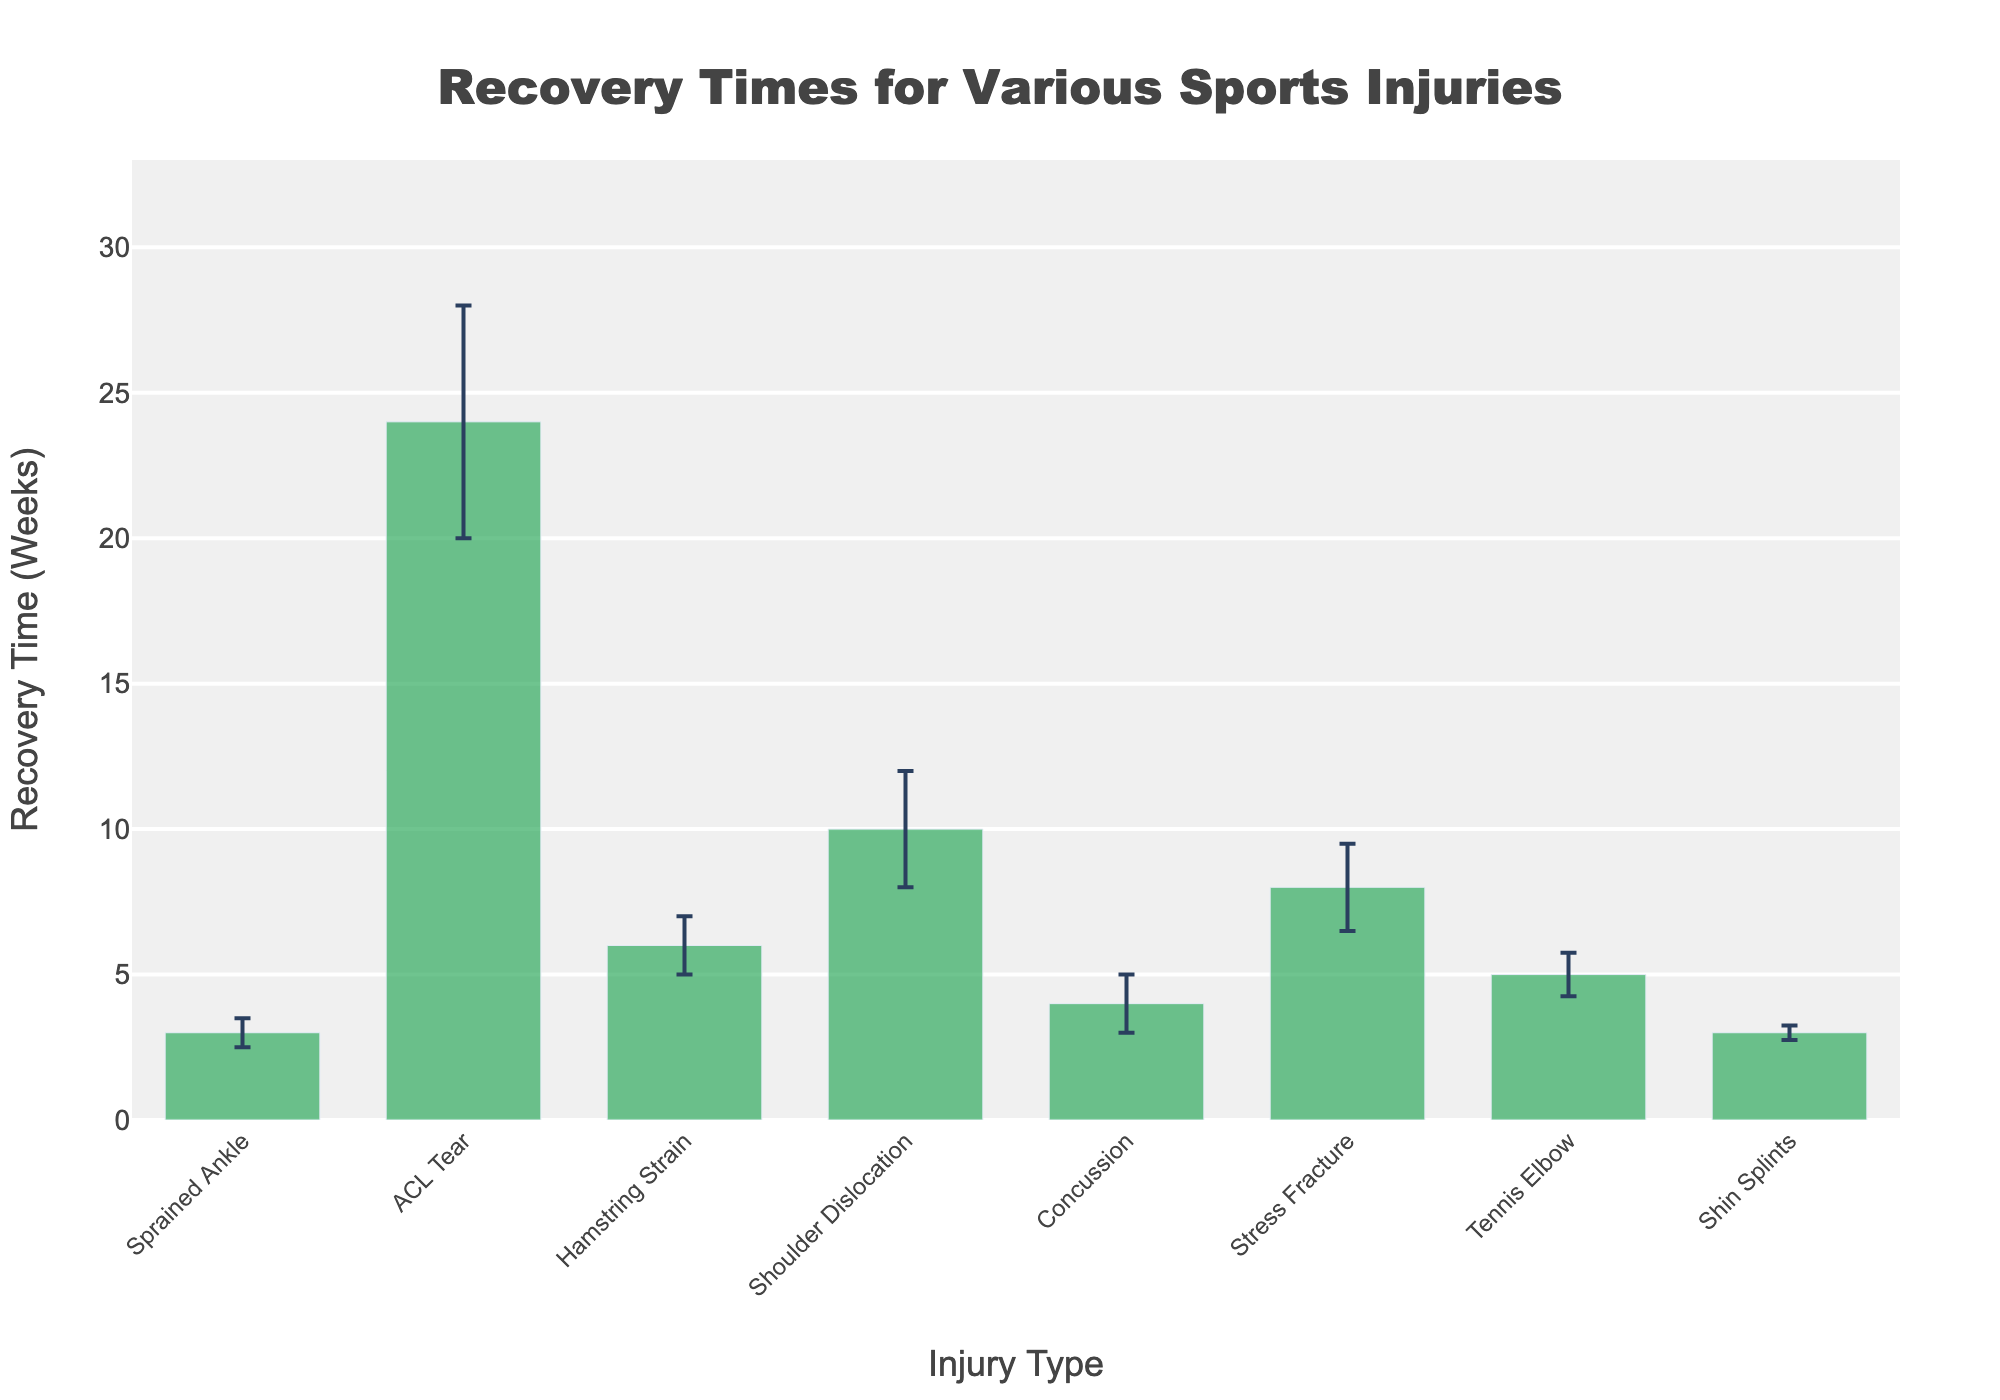what is the title of the plot? The title of the plot is displayed centrally at the top of the figure and reads "Recovery Times for Various Sports Injuries".
Answer: Recovery Times for Various Sports Injuries What is the injury type with the highest average recovery time? The bars represent average recovery times, and the highest bar corresponds to the ACL Tear, which reaches 24 weeks.
Answer: ACL Tear Which injury has the smallest average recovery time? The shortest bar indicates the smallest recovery time, which is for a sprained ankle, at 3 weeks.
Answer: Sprained Ankle What is the average recovery time and standard deviation for a concussion? The bar labeled Concussion shows the average recovery time as 4 weeks, and the error bar indicates the standard deviation is 1 week.
Answer: 4 weeks, 1 week How much longer, on average, does it take to recover from a shoulder dislocation compared to a hamstring strain? The recovery time for a shoulder dislocation is 10 weeks and for a hamstring strain is 6 weeks, so the difference is calculated as 10 - 6 = 4 weeks.
Answer: 4 weeks Which injuries have average recovery times within one standard deviation of 3 weeks? Sprained Ankle (3 ± 0.5), Shin Splints (3 ± 0.25) both fall within one standard deviation of 3 weeks.
Answer: Sprained Ankle, Shin Splints What are the injury types with standard deviations greater than 1 week? By looking at the error bars, ACL Tear (4), Shoulder Dislocation (2), and Stress Fracture (1.5) each have standard deviations greater than 1 week.
Answer: ACL Tear, Shoulder Dislocation, Stress Fracture For which injury types do the recovery times range between 5 to 10 weeks, including standard deviations? Considering average recovery times plus and minus the standard deviation, Hamstring Strain (6±1), Shoulder Dislocation (10±2), Stress Fracture (8±1.5), and Tennis Elbow (5±0.75) fall within this range.
Answer: Hamstring Strain, Shoulder Dislocation, Stress Fracture, Tennis Elbow 